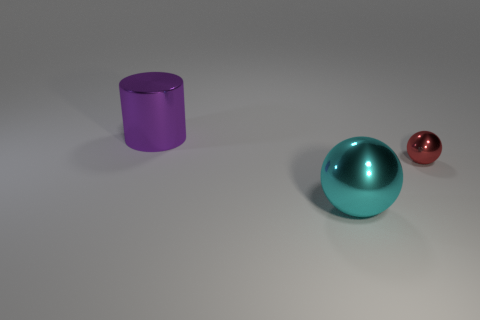Is there anything else that has the same shape as the large purple shiny thing?
Your answer should be very brief. No. What color is the large metallic object that is to the right of the large purple metallic object?
Ensure brevity in your answer.  Cyan. Is the size of the thing to the left of the cyan object the same as the tiny sphere?
Provide a short and direct response. No. What is the size of the cyan metal thing that is the same shape as the red object?
Your response must be concise. Large. Are there any other things that have the same size as the red metal thing?
Keep it short and to the point. No. Does the big cyan shiny thing have the same shape as the red thing?
Ensure brevity in your answer.  Yes. Are there fewer large cylinders that are to the right of the cyan metallic ball than cyan balls that are in front of the red object?
Make the answer very short. Yes. How many big metallic balls are behind the large purple thing?
Offer a very short reply. 0. There is a large thing that is right of the big purple shiny cylinder; is its shape the same as the metal object that is to the right of the cyan shiny thing?
Your response must be concise. Yes. Is the number of tiny balls left of the tiny sphere less than the number of tiny brown things?
Your answer should be compact. No. 